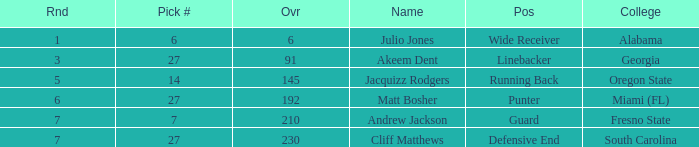Which highest pick number had Akeem Dent as a name and where the overall was less than 91? None. 